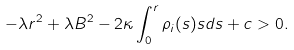<formula> <loc_0><loc_0><loc_500><loc_500>- \lambda r ^ { 2 } + \lambda B ^ { 2 } - 2 \kappa \int _ { 0 } ^ { r } { \rho _ { i } ( s ) s d s } + c > 0 .</formula> 